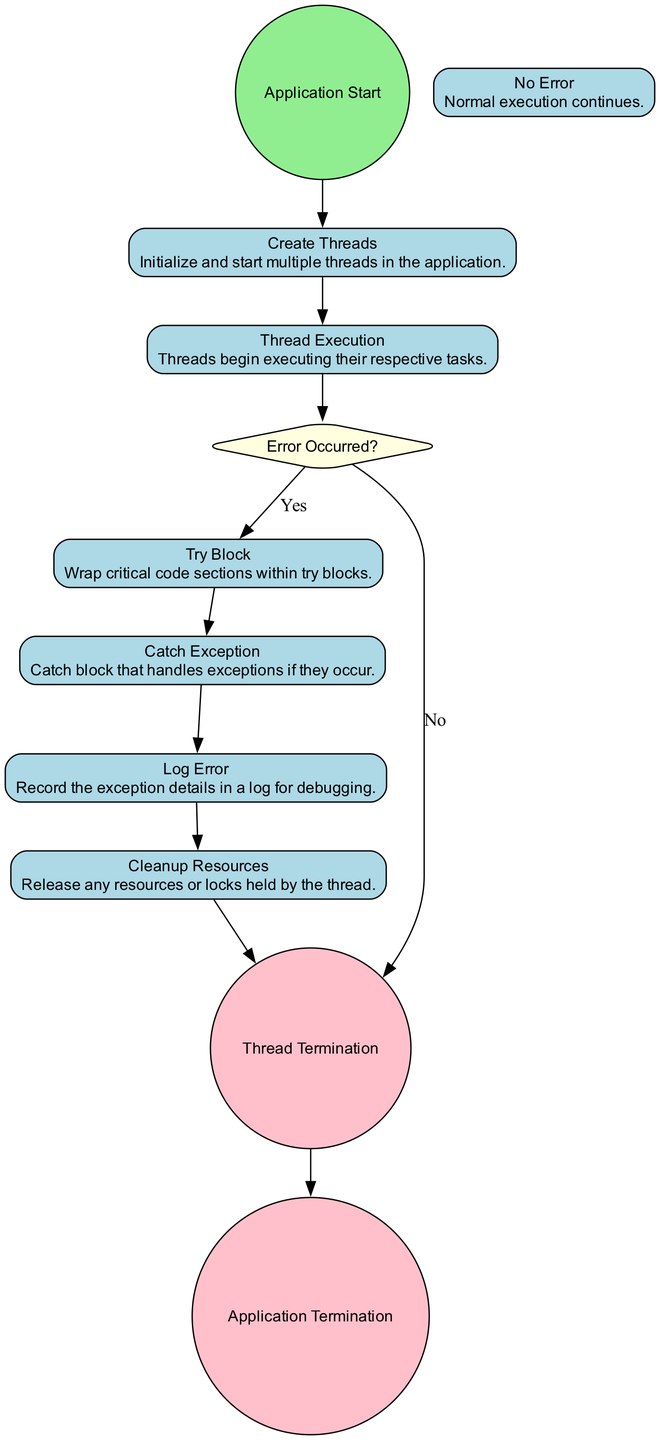What is the starting event of the diagram? The starting event of the diagram is labeled as "Application Start," which signifies the beginning of the flow in the activity diagram.
Answer: Application Start What happens immediately after "Create Threads"? Immediately after "Create Threads," the next action taken is "Thread Execution," representing the threads beginning to execute their tasks.
Answer: Thread Execution How many end events are there in the diagram? There are two end events in the diagram: "Thread Termination" and "Application Termination."
Answer: 2 What is the outcome if an error does not occur? If no error occurs, the flow continues directly to "Thread Termination," indicating that the thread concludes its lifecycle without any issues.
Answer: Thread Termination What action follows after catching an exception? After catching an exception in the "Catch Exception" action, the next step is to "Log Error," which is responsible for recording the details of the exception.
Answer: Log Error What decision makes the flow diverge in the diagram? The decision that causes the flow to diverge is "Error Occurred?", which determines whether to execute the try block or proceed to thread termination.
Answer: Error Occurred? Explain the process of error handling in the threads. In the case that an error is detected (indicated by the "Error Occurred?" decision), the process transfers control to the "Try Block" to manage exceptions. If an exception occurs, it is caught in the "Catch Exception" action, followed by logging the error in "Log Error," and finally, "Cleanup Resources" is executed before reaching "Thread Termination."
Answer: Try Block, Catch Exception, Log Error, Cleanup Resources, Thread Termination Which node represents the normal execution flow? The node labeled "No Error" is representative of the normal execution flow, indicating that everything has proceeded without exceptions.
Answer: No Error What does the "Cleanup Resources" action signify in the diagram? The "Cleanup Resources" action signifies the process of releasing any resources or locks held by the thread to ensure proper resource management after an exception has been handled.
Answer: Cleanup Resources 